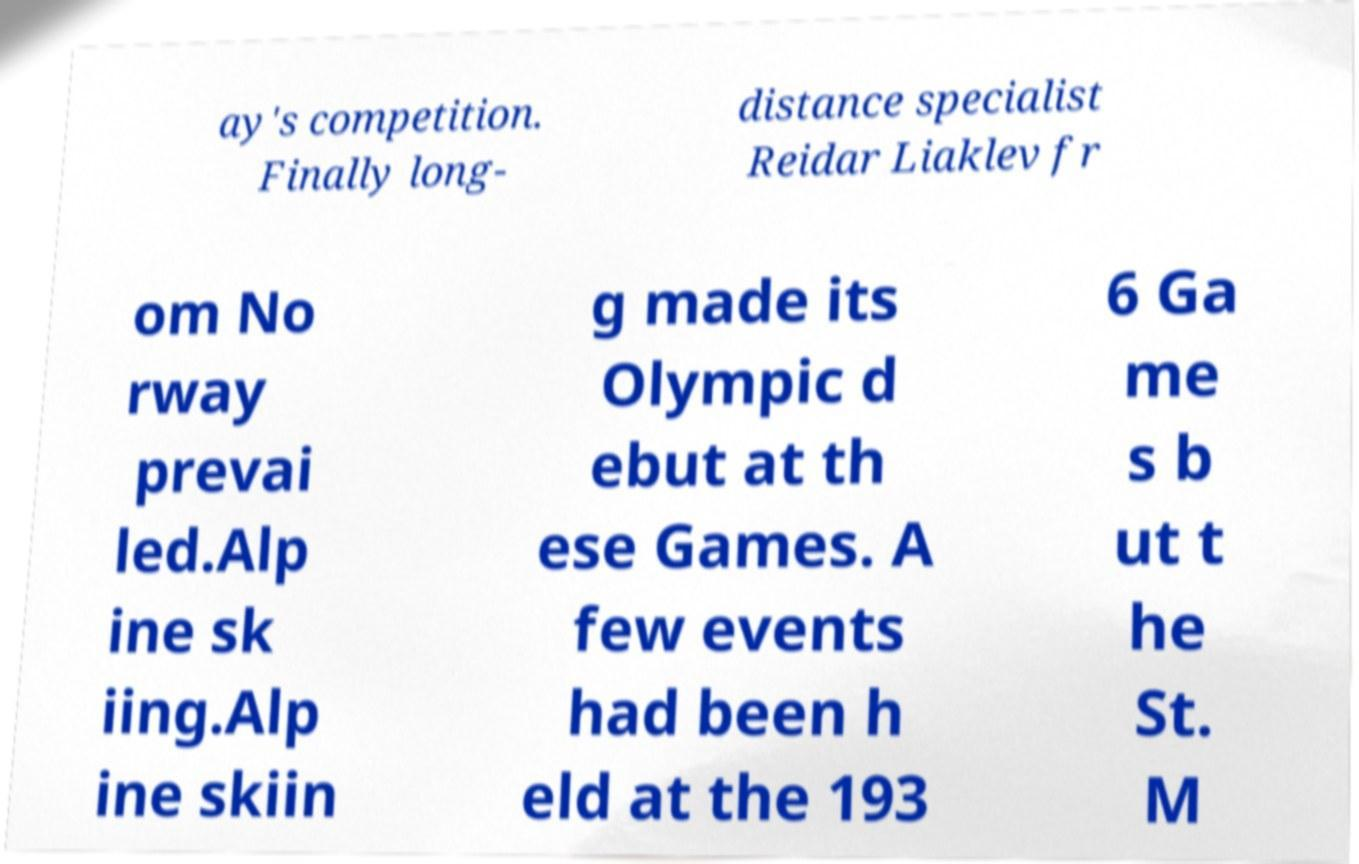There's text embedded in this image that I need extracted. Can you transcribe it verbatim? ay's competition. Finally long- distance specialist Reidar Liaklev fr om No rway prevai led.Alp ine sk iing.Alp ine skiin g made its Olympic d ebut at th ese Games. A few events had been h eld at the 193 6 Ga me s b ut t he St. M 